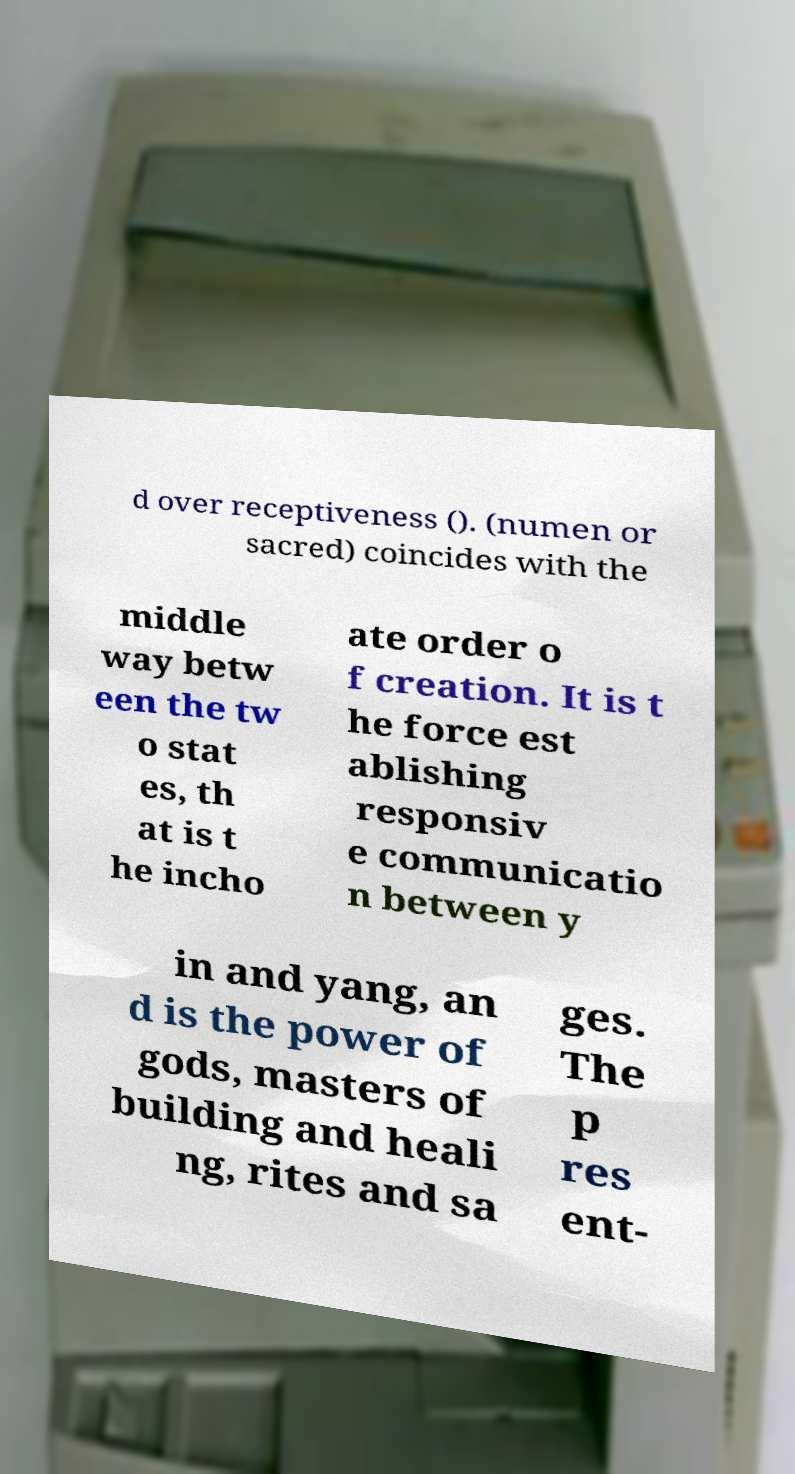Could you extract and type out the text from this image? d over receptiveness (). (numen or sacred) coincides with the middle way betw een the tw o stat es, th at is t he incho ate order o f creation. It is t he force est ablishing responsiv e communicatio n between y in and yang, an d is the power of gods, masters of building and heali ng, rites and sa ges. The p res ent- 